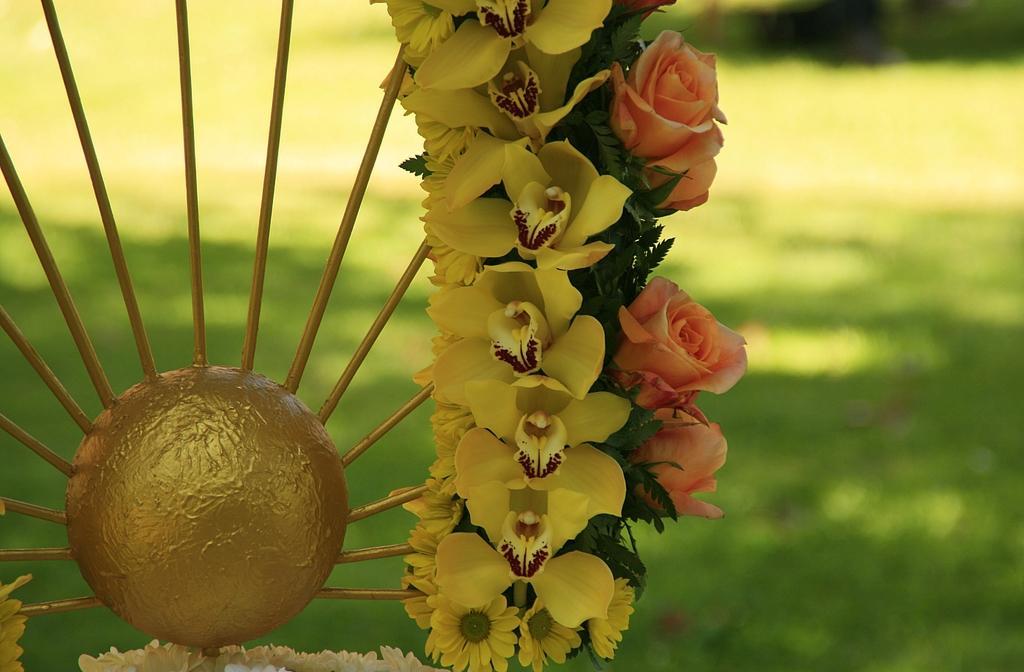In one or two sentences, can you explain what this image depicts? To the left side of the image there is a decorative item with flowers. At the bottom of the image there is grass. 